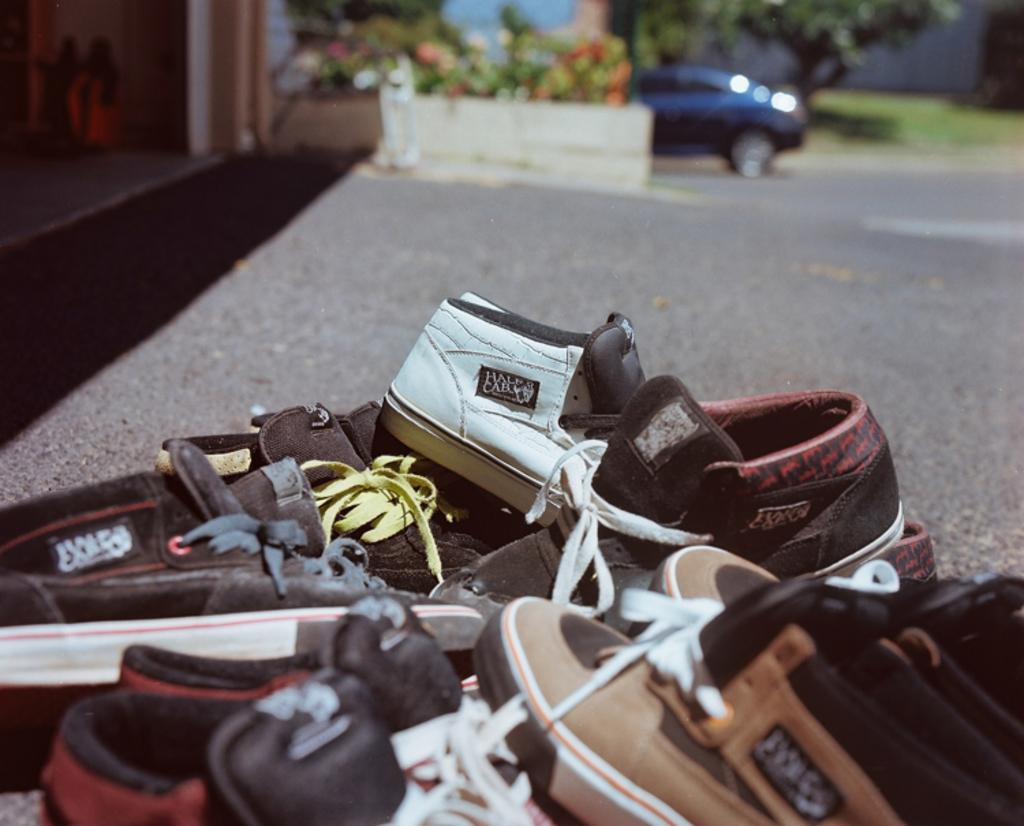What is covering the ground in the image? There are many shoes on the ground in the image. What can be seen in the background of the image? The background is blurred in the image. What type of vehicle is present in the image? There is a car in the image. What type of natural elements can be seen in the image? There are trees in the image. What is the history of the cushion in the image? There is no cushion present in the image. What is the size of the shoes in the image? The size of the shoes cannot be determined from the image alone, as there is no reference for scale. 